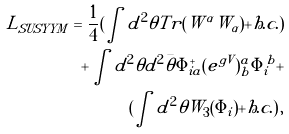Convert formula to latex. <formula><loc_0><loc_0><loc_500><loc_500>L _ { S U S Y Y M } = \frac { 1 } { 4 } ( \int d ^ { 2 } \theta T r ( W ^ { \alpha } W _ { \alpha } ) + h . c . ) \\ + \int d ^ { 2 } \theta d ^ { 2 } \bar { \theta } \Phi ^ { + } _ { i a } ( e ^ { g V } ) ^ { a } _ { b } \Phi ^ { b } _ { i } + \\ ( \int d ^ { 2 } \theta W _ { 3 } ( \Phi _ { i } ) + h . c . ) \, ,</formula> 